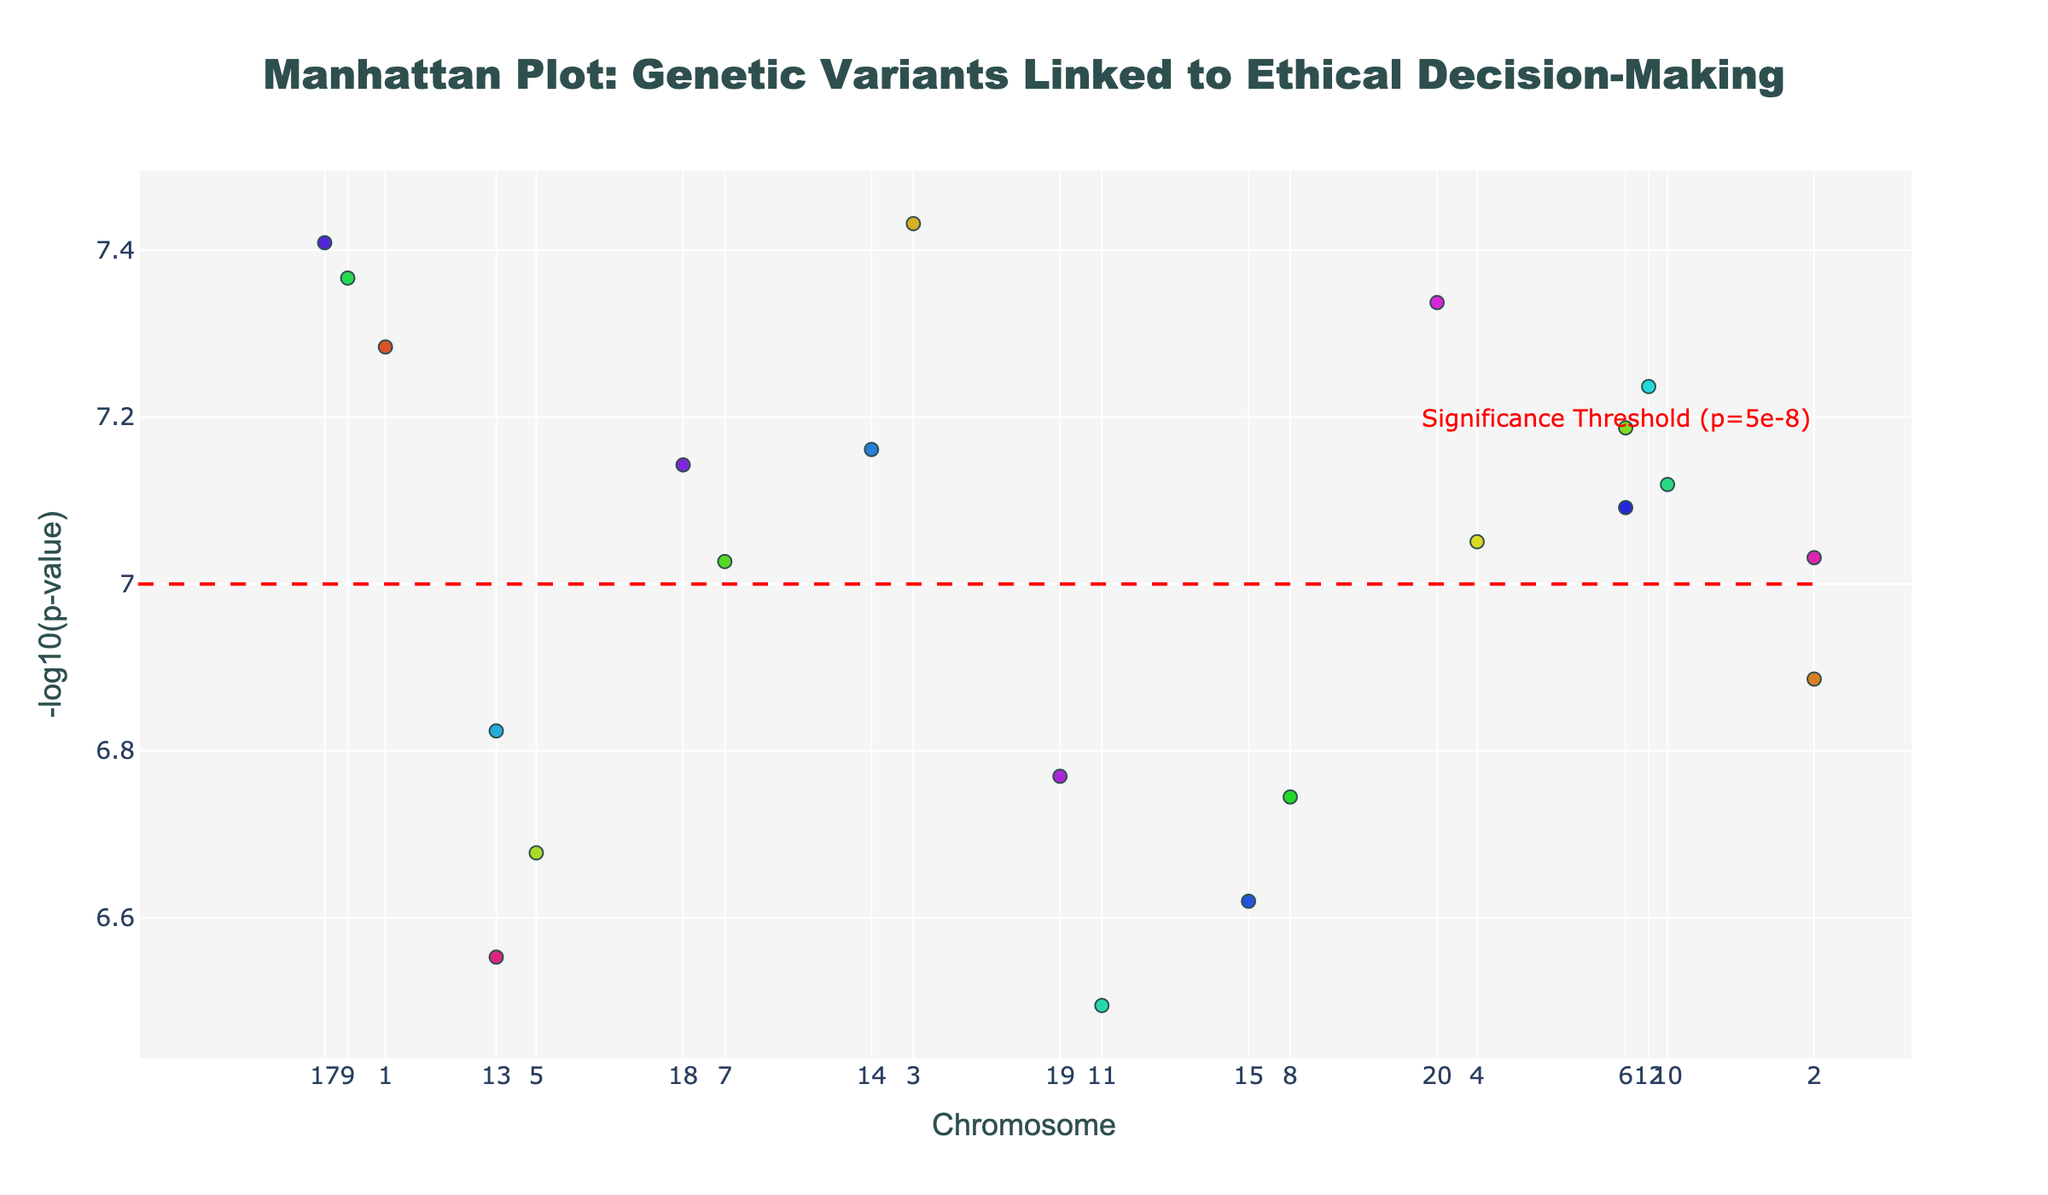What's the title of the figure? The title is typically found at the top of the figure. In this case, it reads: "Manhattan Plot: Genetic Variants Linked to Ethical Decision-Making" which indicates the study focus on ethical traits.
Answer: Manhattan Plot: Genetic Variants Linked to Ethical Decision-Making How many chromosomes are represented in the plot? The x-axis is labeled with numbers representing chromosomes. Since there are chromosome numbers from 1 to 22, the total number of chromosomes represented is 22.
Answer: 22 What is the significance threshold line for the p-value? A horizontal dashed red line, annotated with "Significance Threshold (p=5e-8)" is present at the -log10(p-value) of 7. This value is derived from -log10(5e-8).
Answer: 7 Which chromosome has the highest single -log10(p-value) point? By observing the peaks of the different chromosomes, Chromosome 1 contains the SNP with the highest -log10(p-value).
Answer: Chromosome 1 What is the genetic variant on Chromosome 2 with a significant p-value? We hover over the data points on Chromosome 2 and see that the SNP labeled “rs9876543” associated with the gene DRD4 for the trait Altruism has a significant p-value.
Answer: rs9876543 Which chromosomes have SNPs related to moral decision-making? By examining the hover text for each significant locus, we find that Chromosome 9 has SNPs associated with TPH2, and Chromosome 22 has SNPs associated with TPH2, both traits are related to "moral decision-making".
Answer: Chromosome 9 and Chromosome 22 How many data points have significant p-values below the threshold? Observing the diagram, we can count the number of points that rise above the red line set at -log10(p-value) of 7. There are 9 such points.
Answer: 9 Which SNP is associated with the gene BDNF and what trait does it affect? On Chromosome 6, the hover text identifies SNP rs8765432 associated with the BDNF gene affecting “Prosocial behavior.”
Answer: rs8765432, Prosocial behavior What is the range of positions for the SNPs plotted on Chromosome 10? By examining the x-axis positions for Chromosome 10, the SNP on this chromosome is at position 90123456. The listed SNP positions give the range directly.
Answer: 90123456 Comparatively, which gene related to moral reasoning has a lower p-value: COMT or MAOA? By comparing p-values, the SNP related to COMT on Chromosome 3 (-log10(p-value) of ~7.4) is lower than the SNP related to MAOA on Chromosome 5 (-log10(p-value) of ~6.68).
Answer: COMT 